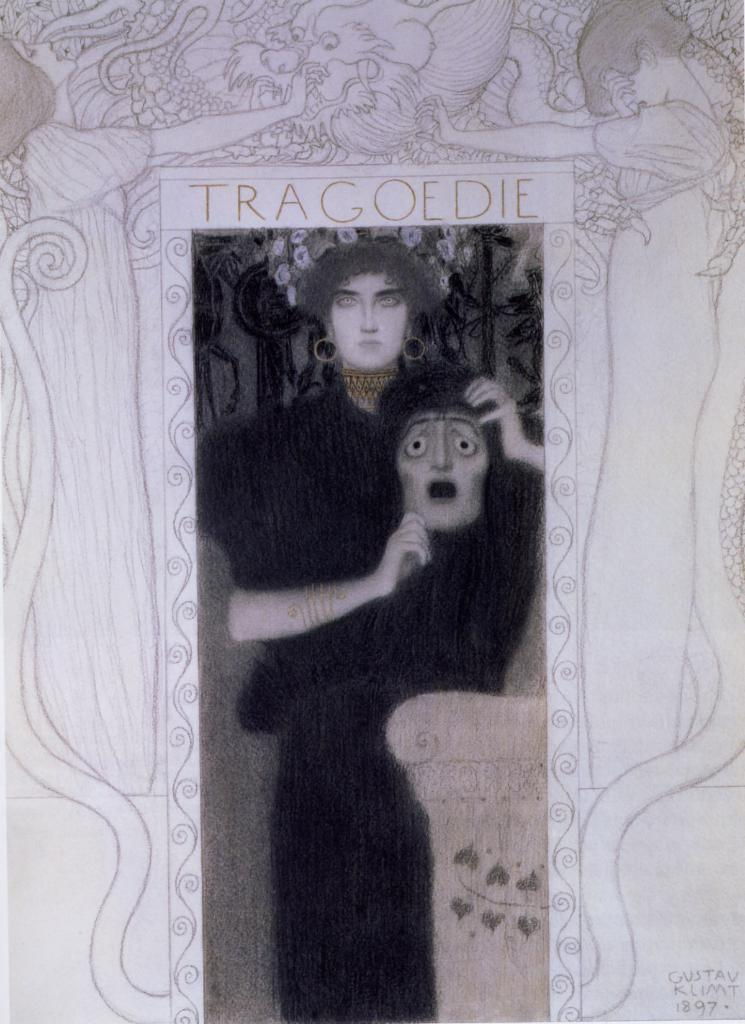What object is present in the image that typically holds a picture? There is a photo frame in the image. What can be seen inside the photo frame? The photo frame contains a picture of a person. What is the person in the picture holding? The person in the picture is holding a mask. Where is the text located in the image? The text is at the right bottom of the image. How many beetles can be seen crawling on the person's mask in the image? There are no beetles visible in the image. 